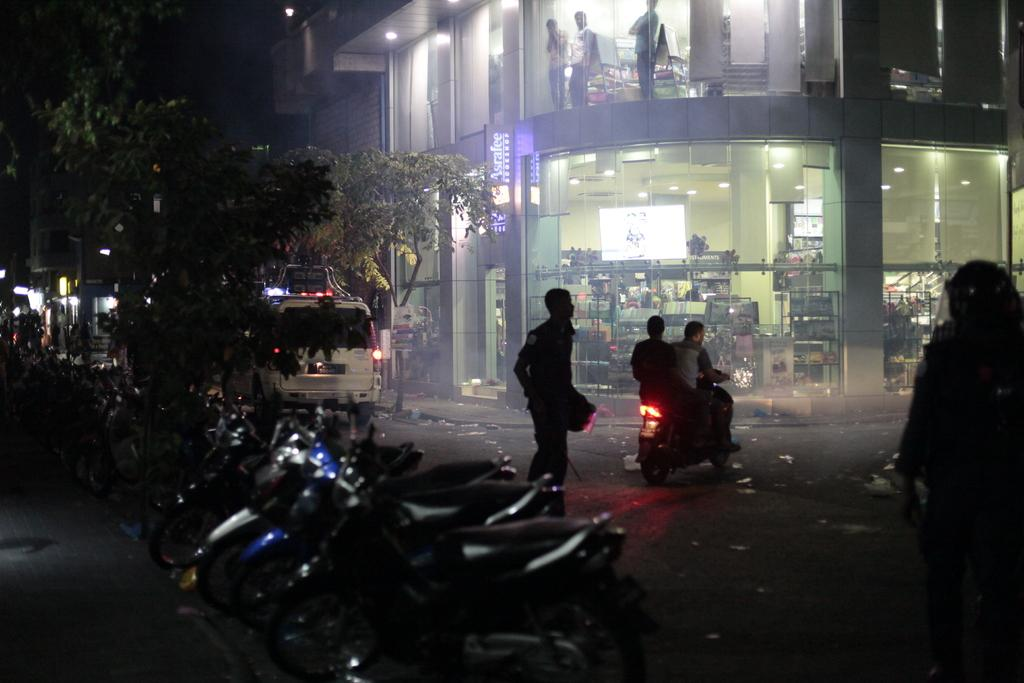What type of structure is visible in the image? There is a building in the image. Are there any living beings present in the image? Yes, there are people in the image. What else can be seen in the image besides the building and people? There are vehicles and a tree visible in the image. Can you describe the interior of the building? In the building, there are people, ceiling lights, and objects. How many geese are present in the building? There are no geese present in the image, let alone inside the building. What type of school is depicted in the image? There is no school present in the image. What appliance can be seen in the building? There is no appliance mentioned or visible in the image. 